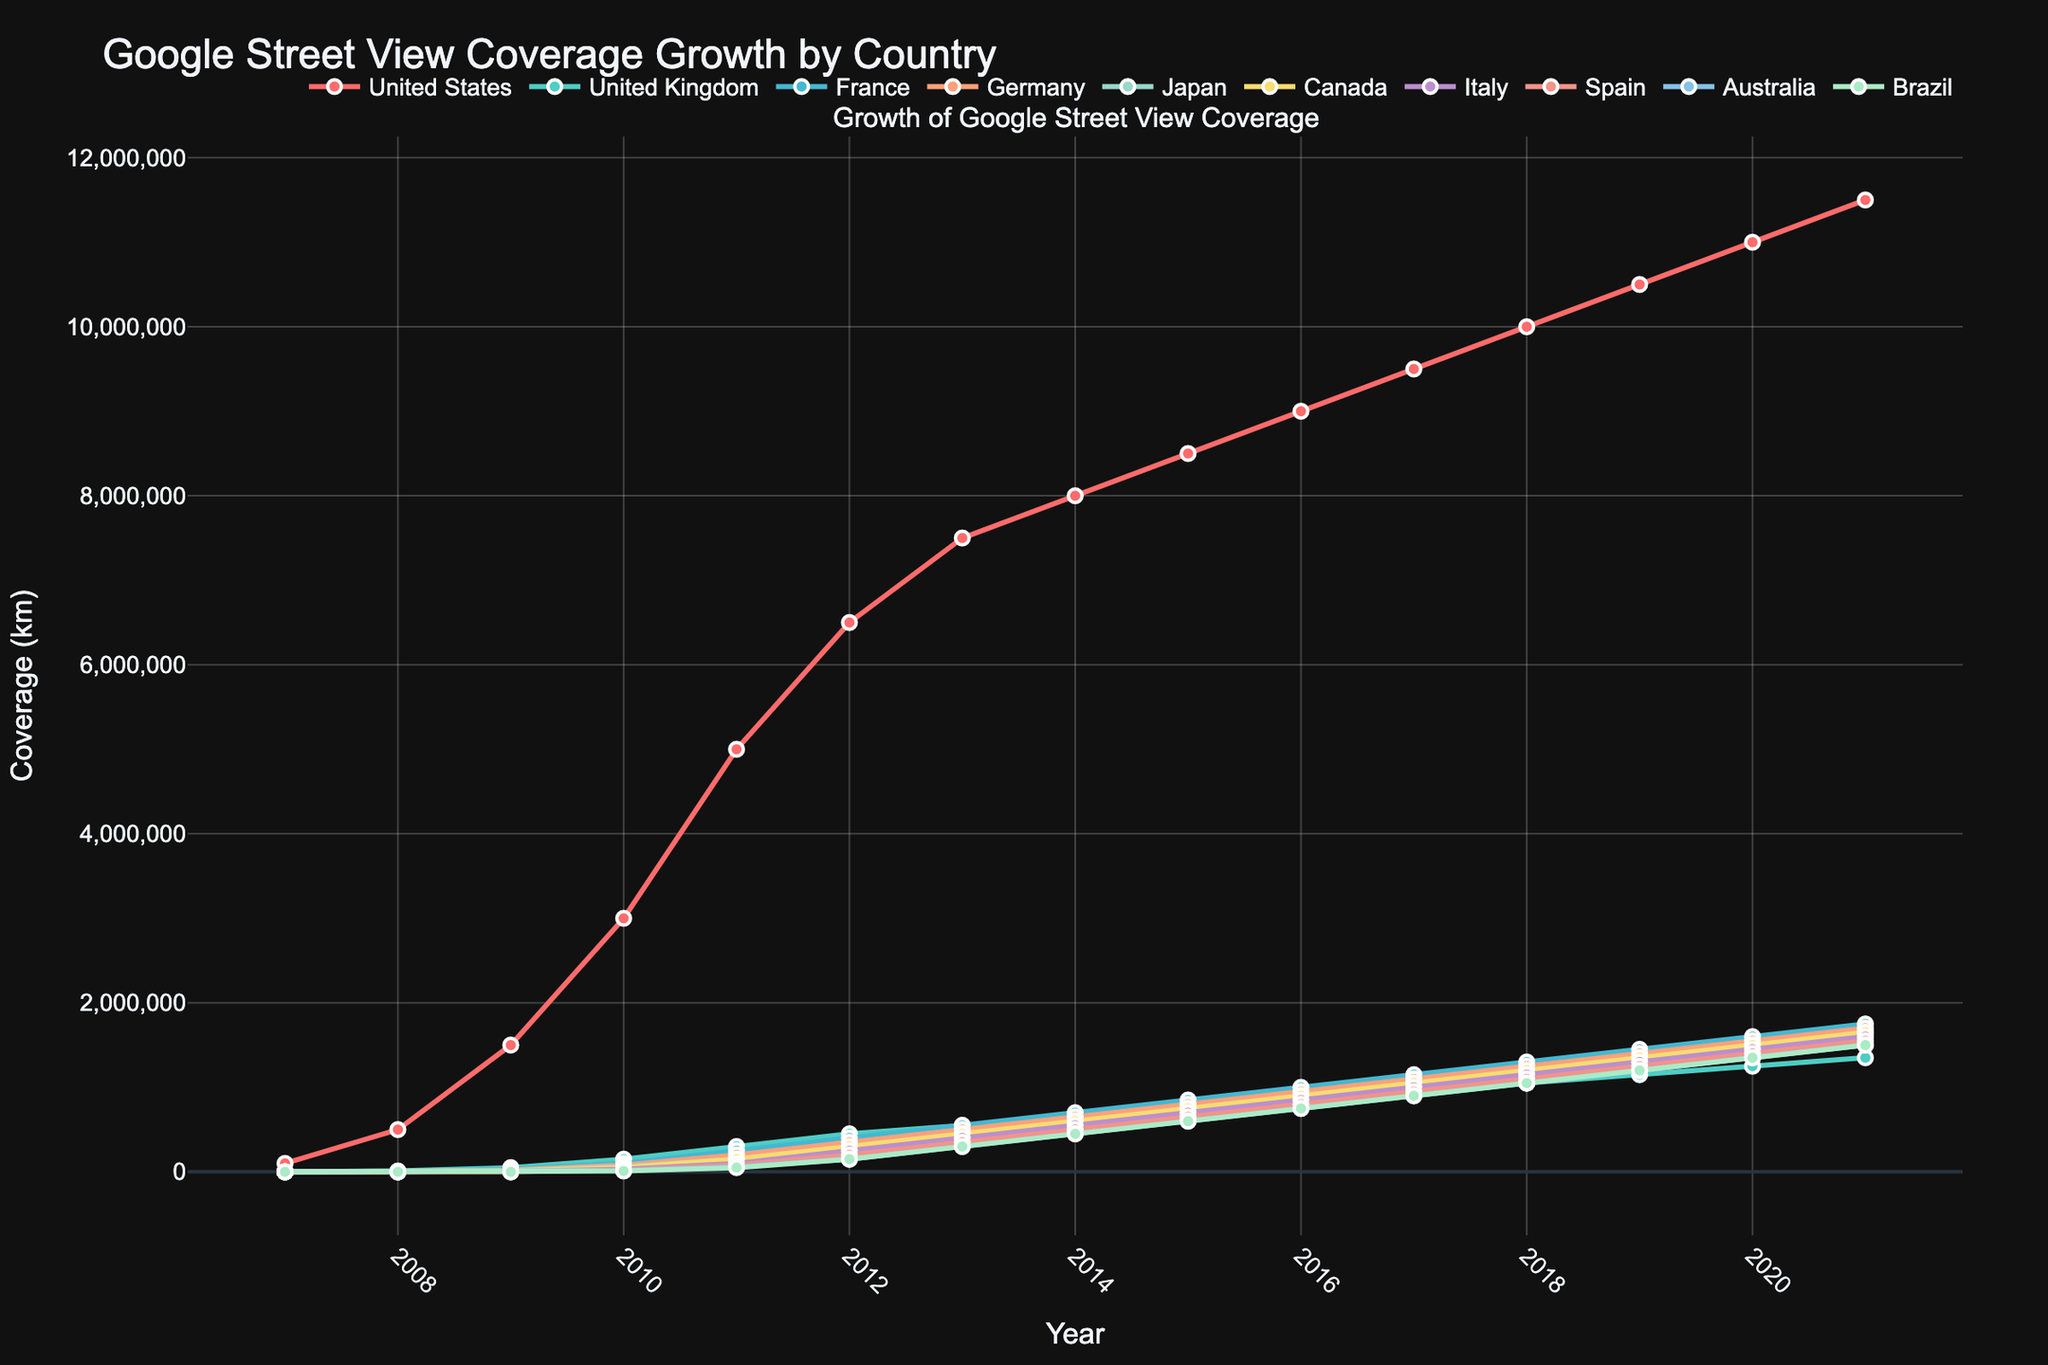what is the coverage growth rate of the United States from 2007 to 2021? To find the coverage growth rate of the United States from 2007 to 2021, first identify the coverage in 2007 and 2021. The values are 100,000 km and 11,500,000 km, respectively. The growth rate is calculated using the formula: [(final value - initial value) / initial value] * 100. 
So, [(11,500,000 - 100,000) / 100,000] * 100 = 11,300%
Answer: 11,300% which country had the lowest Street View coverage in 2011, and what was it? The country with the lowest Street View coverage in 2011 can be identified by comparing the values for each country in 2011. Brazil had the lowest coverage at 50,000 km.
Answer: Brazil, 50,000 km how does the coverage growth of France compare to Germany between 2010 and 2015? Identify the coverage values for France and Germany in 2010 and 2015. For France, it is 100,000 km in 2010 and 850,000 km in 2015. For Germany, it is 80,000 km in 2010 and 800,000 km in 2015. The growth for France is 850,000 - 100,000 = 750,000 km, and for Germany, it is 800,000 - 80,000 = 720,000 km.
France's coverage grew by 750,000 km, while Germany's grew by 720,000 km. France's growth was slightly higher.
Answer: France's growth was higher which year's data shows that Japan had covered 1 million km in Street View? Check the years and corresponding coverage values for Japan and find when it reached 1 million km. Japan reached 1 million km in 2016.
Answer: 2016 which country reached 1,000,000 km in coverage first, Canada or Australia? Look for the year in which both Canada and Australia reached 1,000,000 km of coverage. Canada and Australia both reached it in 2016.
Both countries reached 1,000,000 km in 2016.
Answer: Both in 2016 what is the color used to represent Italy in the figure? Refer to the line color associated with Italy. Italy is represented by a purple line in the chart.
Answer: Purple calculate and compare the average coverage of Brazil and Spain between 2015 and 2020. Identify the yearly coverage values from 2015 to 2020 for Brazil and Spain. For Brazil: 750,000, 900,000, 1,050,000, 1,200,000, 1,350,000, 1,500,000. For Spain: 800,000, 950,000, 1,100,000, 1,250,000, 1,400,000, 1,550,000.
Calculate average: Brazil: (750,000 + 900,000 + 1,050,000 + 1,200,000 + 1,350,000 + 1,500,000) / 6 = 1,125,000 km, Spain: (800,000 + 950,000 + 1,100,000 + 1,250,000 + 1,400,000 + 1,550,000) / 6 = 1,175,000 km.
Spain's average coverage is slightly higher than Brazil's.
Answer: Spain's average is higher 